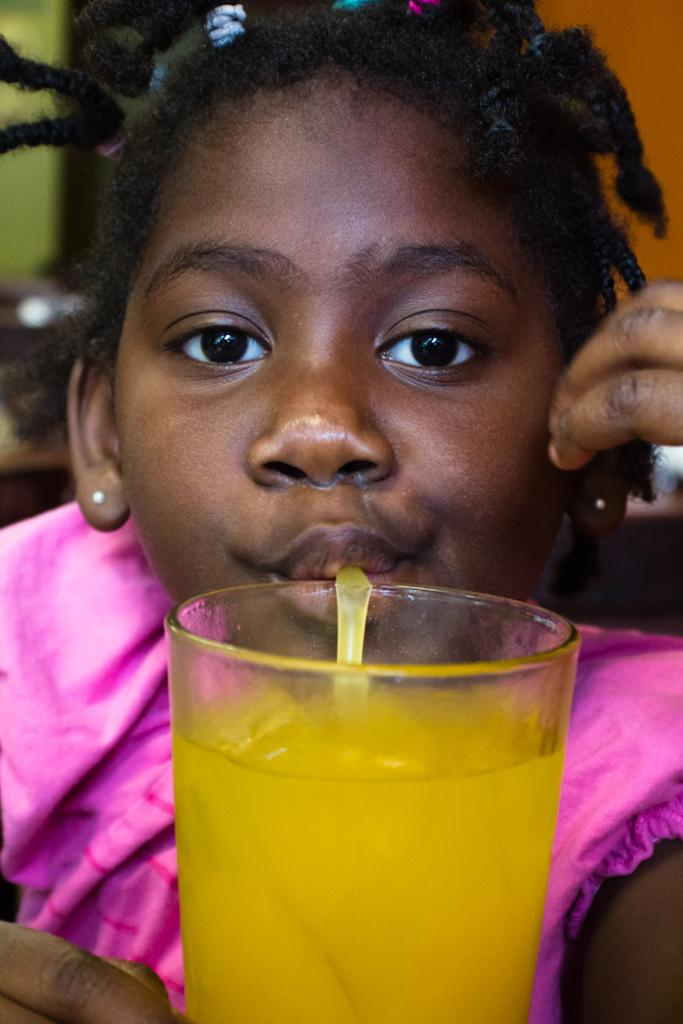Who is the main subject in the image? There is a girl in the image. What is in front of the girl? There is a glass in front of the girl. What is the girl doing with the glass? The girl is drinking something. What type of island can be seen in the background of the image? There is no island visible in the image; it only features a girl and a glass. 